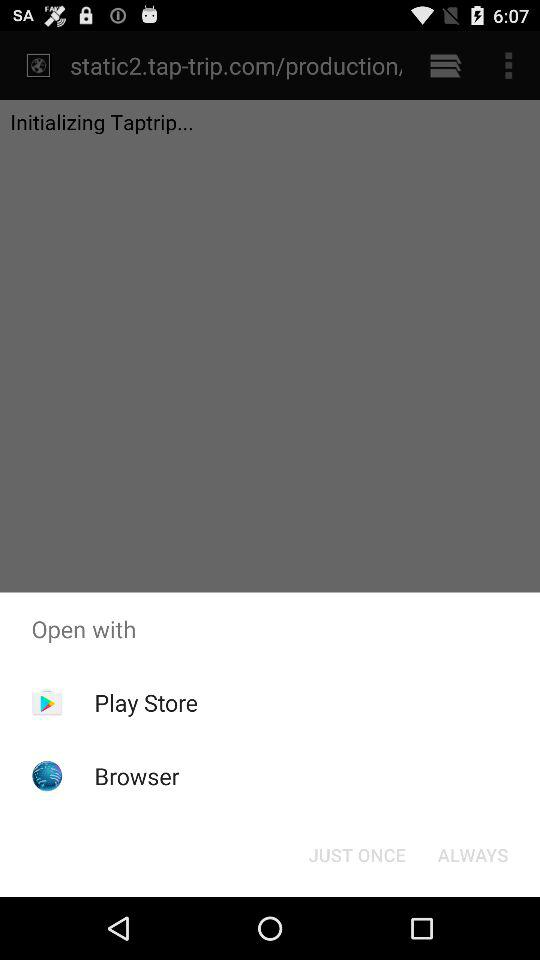Which application is selected to open the content?
When the provided information is insufficient, respond with <no answer>. <no answer> 